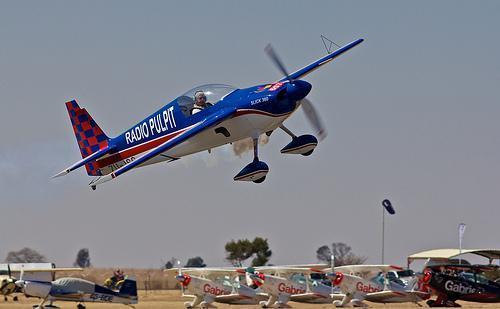How many propellers on the airborne plant?
Give a very brief answer. 1. 